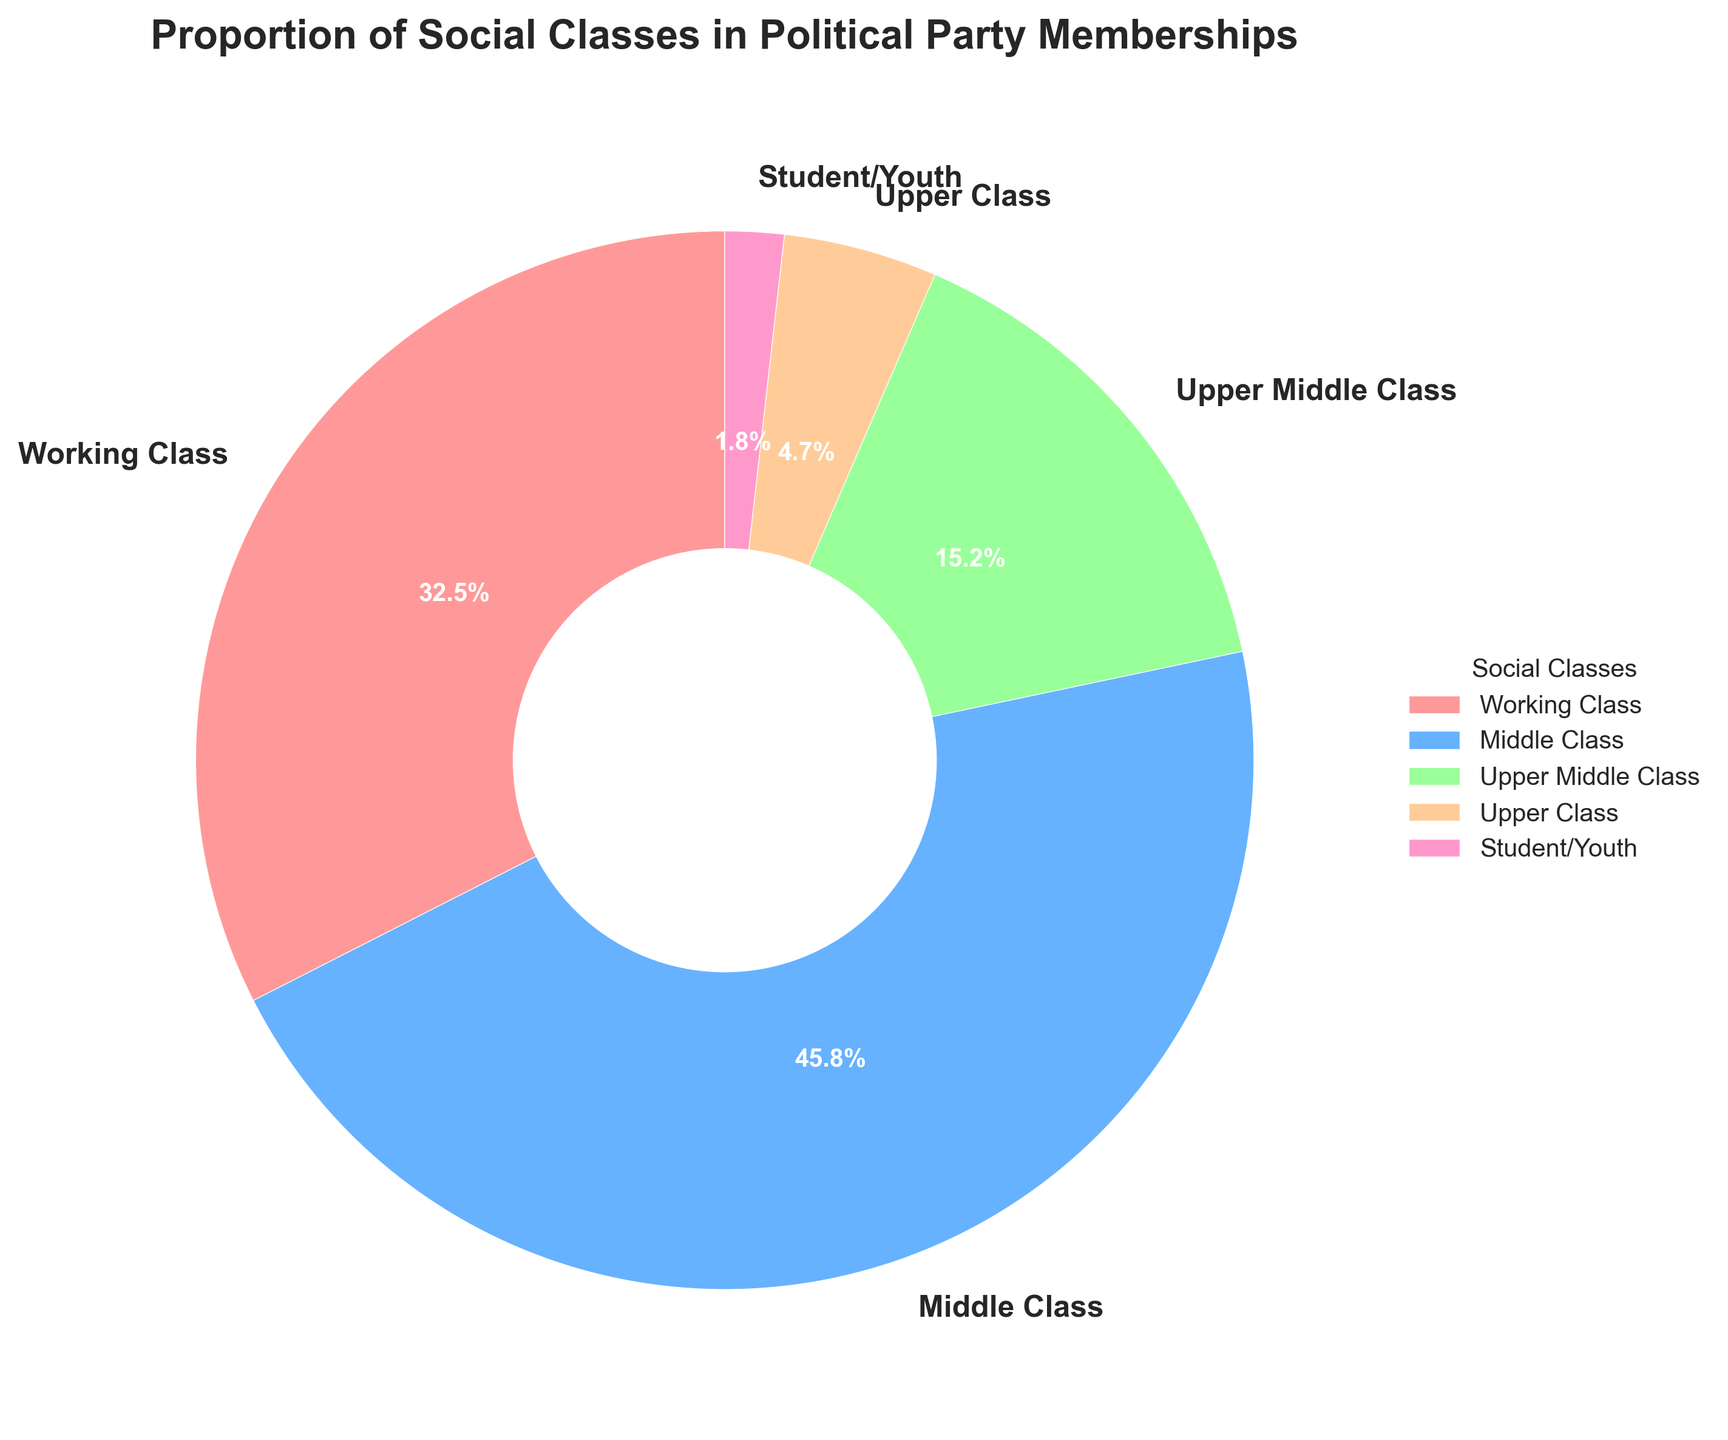What are the proportions of Working Class and Student/Youth combined in political party memberships? To find the combined proportion, add the percentage of Working Class and Student/Youth. Working Class is 32.5% and Student/Youth is 1.8%. Therefore, the combined proportion is 32.5% + 1.8% = 34.3%.
Answer: 34.3% Which social class has the smallest representation in political party memberships? The smallest percentage of representation in the pie chart is Student/Youth at 1.8%.
Answer: Student/Youth Is the proportion of Middle Class members greater than the combined proportion of Upper Middle Class and Upper Class members? Middle Class members constitute 45.8%. Upper Middle Class members are 15.2% and Upper Class members are 4.7%. Their combined proportion is 15.2% + 4.7% = 19.9%. Since 45.8% is greater than 19.9%, the answer is yes.
Answer: Yes What is the difference in the proportion between Middle Class and Working Class members? The proportion of Middle Class members is 45.8% and that of Working Class members is 32.5%. The difference is 45.8% - 32.5% = 13.3%.
Answer: 13.3% Combine the proportion of Upper Middle Class and Upper Class members. Is this combination bigger or smaller than the proportion of Working Class members? Upper Middle Class is 15.2% and Upper Class is 4.7%. Combined, they make 15.2% + 4.7% = 19.9%. Working Class is 32.5%, which is bigger than 19.9%.
Answer: Smaller Which social class has the largest slice in the pie chart, and what is its corresponding percentage? The Middle Class has the largest slice in the pie chart with a percentage of 45.8%.
Answer: Middle Class, 45.8% What visual attribute distinguishes the different slices in the pie chart? Each slice of the pie chart is distinguished by a different color, ensuring easy identification of social classes. Additionally, each slice is labeled with the class name and percentage.
Answer: Colors and Labels What is the combined proportion of Upper Middle Class, Upper Class, and Student/Youth members? The combined proportion is the sum of the percentages: Upper Middle Class (15.2%) + Upper Class (4.7%) + Student/Youth (1.8%). Therefore, the combined proportion is 15.2% + 4.7% + 1.8% = 21.7%.
Answer: 21.7% Which social classes have proportions that are less than 20%? The social classes with proportions less than 20% are Upper Middle Class (15.2%), Upper Class (4.7%), and Student/Youth (1.8%).
Answer: Upper Middle Class, Upper Class, Student/Youth 